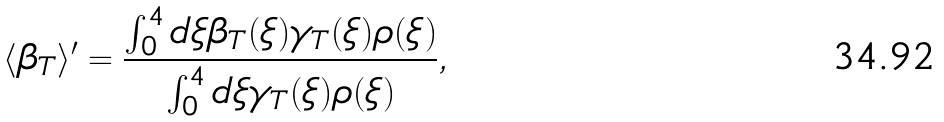<formula> <loc_0><loc_0><loc_500><loc_500>\langle \beta _ { T } \rangle ^ { \prime } = \frac { \int _ { 0 } ^ { 4 } d \xi \beta _ { T } ( \xi ) \gamma _ { T } ( \xi ) \rho ( \xi ) } { \int _ { 0 } ^ { 4 } d \xi \gamma _ { T } ( \xi ) \rho ( \xi ) } ,</formula> 